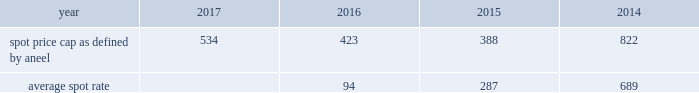31 , 2015 , the price was r$ 218/mwh .
After the expiration of contract with eletropaulo , tiet ea's strategy is to contract most of its physical guarantee , as described in regulatory framework section below , and sell the remaining portion in the spot market .
Tiet ea's strategy is reassessed from time to time according to changes in market conditions , hydrology and other factors .
Tiet ea has been continuously selling its available energy from 2016 forward through medium-term bilateral contracts of three to five years .
As of december 31 , 2016 , tiet ea's contracted portfolio position is 95% ( 95 % ) and 88% ( 88 % ) with average prices of r$ 157/ mwh and r$ 159/mwh ( inflation adjusted until december 2016 ) for 2016 and 2017 , respectively .
As brazil is mostly a hydro-based country with energy prices highly tied to the hydrological situation , the deterioration of the hydrology since the beginning of 2014 caused an increase in energy prices going forward .
Tiet ea is closely monitoring and analyzing system supply conditions to support energy commercialization decisions .
Under the concession agreement , tiet ea has an obligation to increase its capacity by 15% ( 15 % ) .
Tiet ea , as well as other concession generators , have not yet met this requirement due to regulatory , environmental , hydrological and fuel constraints .
The state of s e3o paulo does not have a sufficient potential for wind power and only has a small remaining potential for hydro projects .
As such , the capacity increases in the state will mostly be derived from thermal gas capacity projects .
Due to the highly complex process to obtain an environmental license for coal projects , tiet ea decided to fulfill its obligation with gas-fired projects in line with the federal government plans .
Petrobras refuses to supply natural gas and to offer capacity in its pipelines and regasification terminals .
Therefore , there are no regulations for natural gas swaps in place , and it is unfeasible to bring natural gas to aes tiet ea .
A legal case has been initiated by the state of s e3o paulo requiring the investment to be performed .
Tiet ea is in the process of analyzing options to meet the obligation .
Uruguaiana is a 640 mw gas-fired combined cycle power plant located in the town of uruguaiana in the state of rio grande do sul , commissioned in december 2000 .
Aes manages and has a 46% ( 46 % ) economic interest in the plant with the remaining interest held by bndes .
The plant's operations were suspended in april 2009 due to the unavailability of gas .
Aes has evaluated several alternatives to bring gas supply on a competitive basis to uruguaiana .
One of the challenges is the capacity restrictions on the argentinean pipeline , especially during the winter season when gas demand in argentina is very high .
The plant operated on a short-term basis during february and march 2013 , march through may 2014 , and february through may 2015 due to the short-term supply of lng for the facility .
The plant did not operate in 2016 .
Uruguaiana continues to work toward securing gas on a long-term basis .
Market structure 2014 brazil has installed capacity of 150136 mw , which is 65% ( 65 % ) hydroelectric , 19% ( 19 % ) thermal and 16% ( 16 % ) renewable ( biomass and wind ) .
Brazil's national grid is divided into four subsystems .
Tiet ea is in the southeast and uruguaiana is in the south subsystems of the national grid .
Regulatory framework 2014 in brazil , the ministry of mines and energy determines the maximum amount of energy that a plant can sell , called physical guarantee , which represents the long-term average expected energy production of the plant .
Under current rules , physical guarantee can be sold to distribution companies through long- term regulated auctions or under unregulated bilateral contracts with large consumers or energy trading companies .
The national system operator ( "ons" ) is responsible for coordinating and controlling the operation of the national grid .
The ons dispatches generators based on hydrological conditions , reservoir levels , electricity demand and the prices of fuel and thermal generation .
Given the importance of hydro generation in the country , the ons sometimes reduces dispatch of hydro facilities and increases dispatch of thermal facilities to protect reservoir levels in the system .
In brazil , the system operator controls all hydroelectric generation dispatch and reservoir levels .
A mechanism known as the energy reallocation mechanism ( "mre" ) was created to share hydrological risk across mre hydro generators .
If the hydro plants generate less than the total mre physical guarantee , the hydro generators may need to purchase energy in the short-term market to fulfill their contract obligations .
When total hydro generation is higher than the total mre physical guarantee , the surplus is proportionally shared among its participants and they are able to make extra revenue selling the excess energy on the spot market .
The consequences of unfavorable hydrology are ( i ) thermal plants more expensive to the system being dispatched , ( ii ) lower hydropower generation with deficits in the mre and ( iii ) high spot prices .
Aneel defines the spot price cap for electricity in the brazilian market .
The spot price caps as defined by aneel and average spot prices by calendar year are as follows ( r$ / .

What was the percentage change in the average spot rate between 2015 to 2016? 
Computations: ((94 - 287) / 287)
Answer: -0.67247. 31 , 2015 , the price was r$ 218/mwh .
After the expiration of contract with eletropaulo , tiet ea's strategy is to contract most of its physical guarantee , as described in regulatory framework section below , and sell the remaining portion in the spot market .
Tiet ea's strategy is reassessed from time to time according to changes in market conditions , hydrology and other factors .
Tiet ea has been continuously selling its available energy from 2016 forward through medium-term bilateral contracts of three to five years .
As of december 31 , 2016 , tiet ea's contracted portfolio position is 95% ( 95 % ) and 88% ( 88 % ) with average prices of r$ 157/ mwh and r$ 159/mwh ( inflation adjusted until december 2016 ) for 2016 and 2017 , respectively .
As brazil is mostly a hydro-based country with energy prices highly tied to the hydrological situation , the deterioration of the hydrology since the beginning of 2014 caused an increase in energy prices going forward .
Tiet ea is closely monitoring and analyzing system supply conditions to support energy commercialization decisions .
Under the concession agreement , tiet ea has an obligation to increase its capacity by 15% ( 15 % ) .
Tiet ea , as well as other concession generators , have not yet met this requirement due to regulatory , environmental , hydrological and fuel constraints .
The state of s e3o paulo does not have a sufficient potential for wind power and only has a small remaining potential for hydro projects .
As such , the capacity increases in the state will mostly be derived from thermal gas capacity projects .
Due to the highly complex process to obtain an environmental license for coal projects , tiet ea decided to fulfill its obligation with gas-fired projects in line with the federal government plans .
Petrobras refuses to supply natural gas and to offer capacity in its pipelines and regasification terminals .
Therefore , there are no regulations for natural gas swaps in place , and it is unfeasible to bring natural gas to aes tiet ea .
A legal case has been initiated by the state of s e3o paulo requiring the investment to be performed .
Tiet ea is in the process of analyzing options to meet the obligation .
Uruguaiana is a 640 mw gas-fired combined cycle power plant located in the town of uruguaiana in the state of rio grande do sul , commissioned in december 2000 .
Aes manages and has a 46% ( 46 % ) economic interest in the plant with the remaining interest held by bndes .
The plant's operations were suspended in april 2009 due to the unavailability of gas .
Aes has evaluated several alternatives to bring gas supply on a competitive basis to uruguaiana .
One of the challenges is the capacity restrictions on the argentinean pipeline , especially during the winter season when gas demand in argentina is very high .
The plant operated on a short-term basis during february and march 2013 , march through may 2014 , and february through may 2015 due to the short-term supply of lng for the facility .
The plant did not operate in 2016 .
Uruguaiana continues to work toward securing gas on a long-term basis .
Market structure 2014 brazil has installed capacity of 150136 mw , which is 65% ( 65 % ) hydroelectric , 19% ( 19 % ) thermal and 16% ( 16 % ) renewable ( biomass and wind ) .
Brazil's national grid is divided into four subsystems .
Tiet ea is in the southeast and uruguaiana is in the south subsystems of the national grid .
Regulatory framework 2014 in brazil , the ministry of mines and energy determines the maximum amount of energy that a plant can sell , called physical guarantee , which represents the long-term average expected energy production of the plant .
Under current rules , physical guarantee can be sold to distribution companies through long- term regulated auctions or under unregulated bilateral contracts with large consumers or energy trading companies .
The national system operator ( "ons" ) is responsible for coordinating and controlling the operation of the national grid .
The ons dispatches generators based on hydrological conditions , reservoir levels , electricity demand and the prices of fuel and thermal generation .
Given the importance of hydro generation in the country , the ons sometimes reduces dispatch of hydro facilities and increases dispatch of thermal facilities to protect reservoir levels in the system .
In brazil , the system operator controls all hydroelectric generation dispatch and reservoir levels .
A mechanism known as the energy reallocation mechanism ( "mre" ) was created to share hydrological risk across mre hydro generators .
If the hydro plants generate less than the total mre physical guarantee , the hydro generators may need to purchase energy in the short-term market to fulfill their contract obligations .
When total hydro generation is higher than the total mre physical guarantee , the surplus is proportionally shared among its participants and they are able to make extra revenue selling the excess energy on the spot market .
The consequences of unfavorable hydrology are ( i ) thermal plants more expensive to the system being dispatched , ( ii ) lower hydropower generation with deficits in the mre and ( iii ) high spot prices .
Aneel defines the spot price cap for electricity in the brazilian market .
The spot price caps as defined by aneel and average spot prices by calendar year are as follows ( r$ / .

What was the percentage change in the average spot rate between 2014 to 2015? 
Computations: ((287 - 689) / 689)
Answer: -0.58345. 